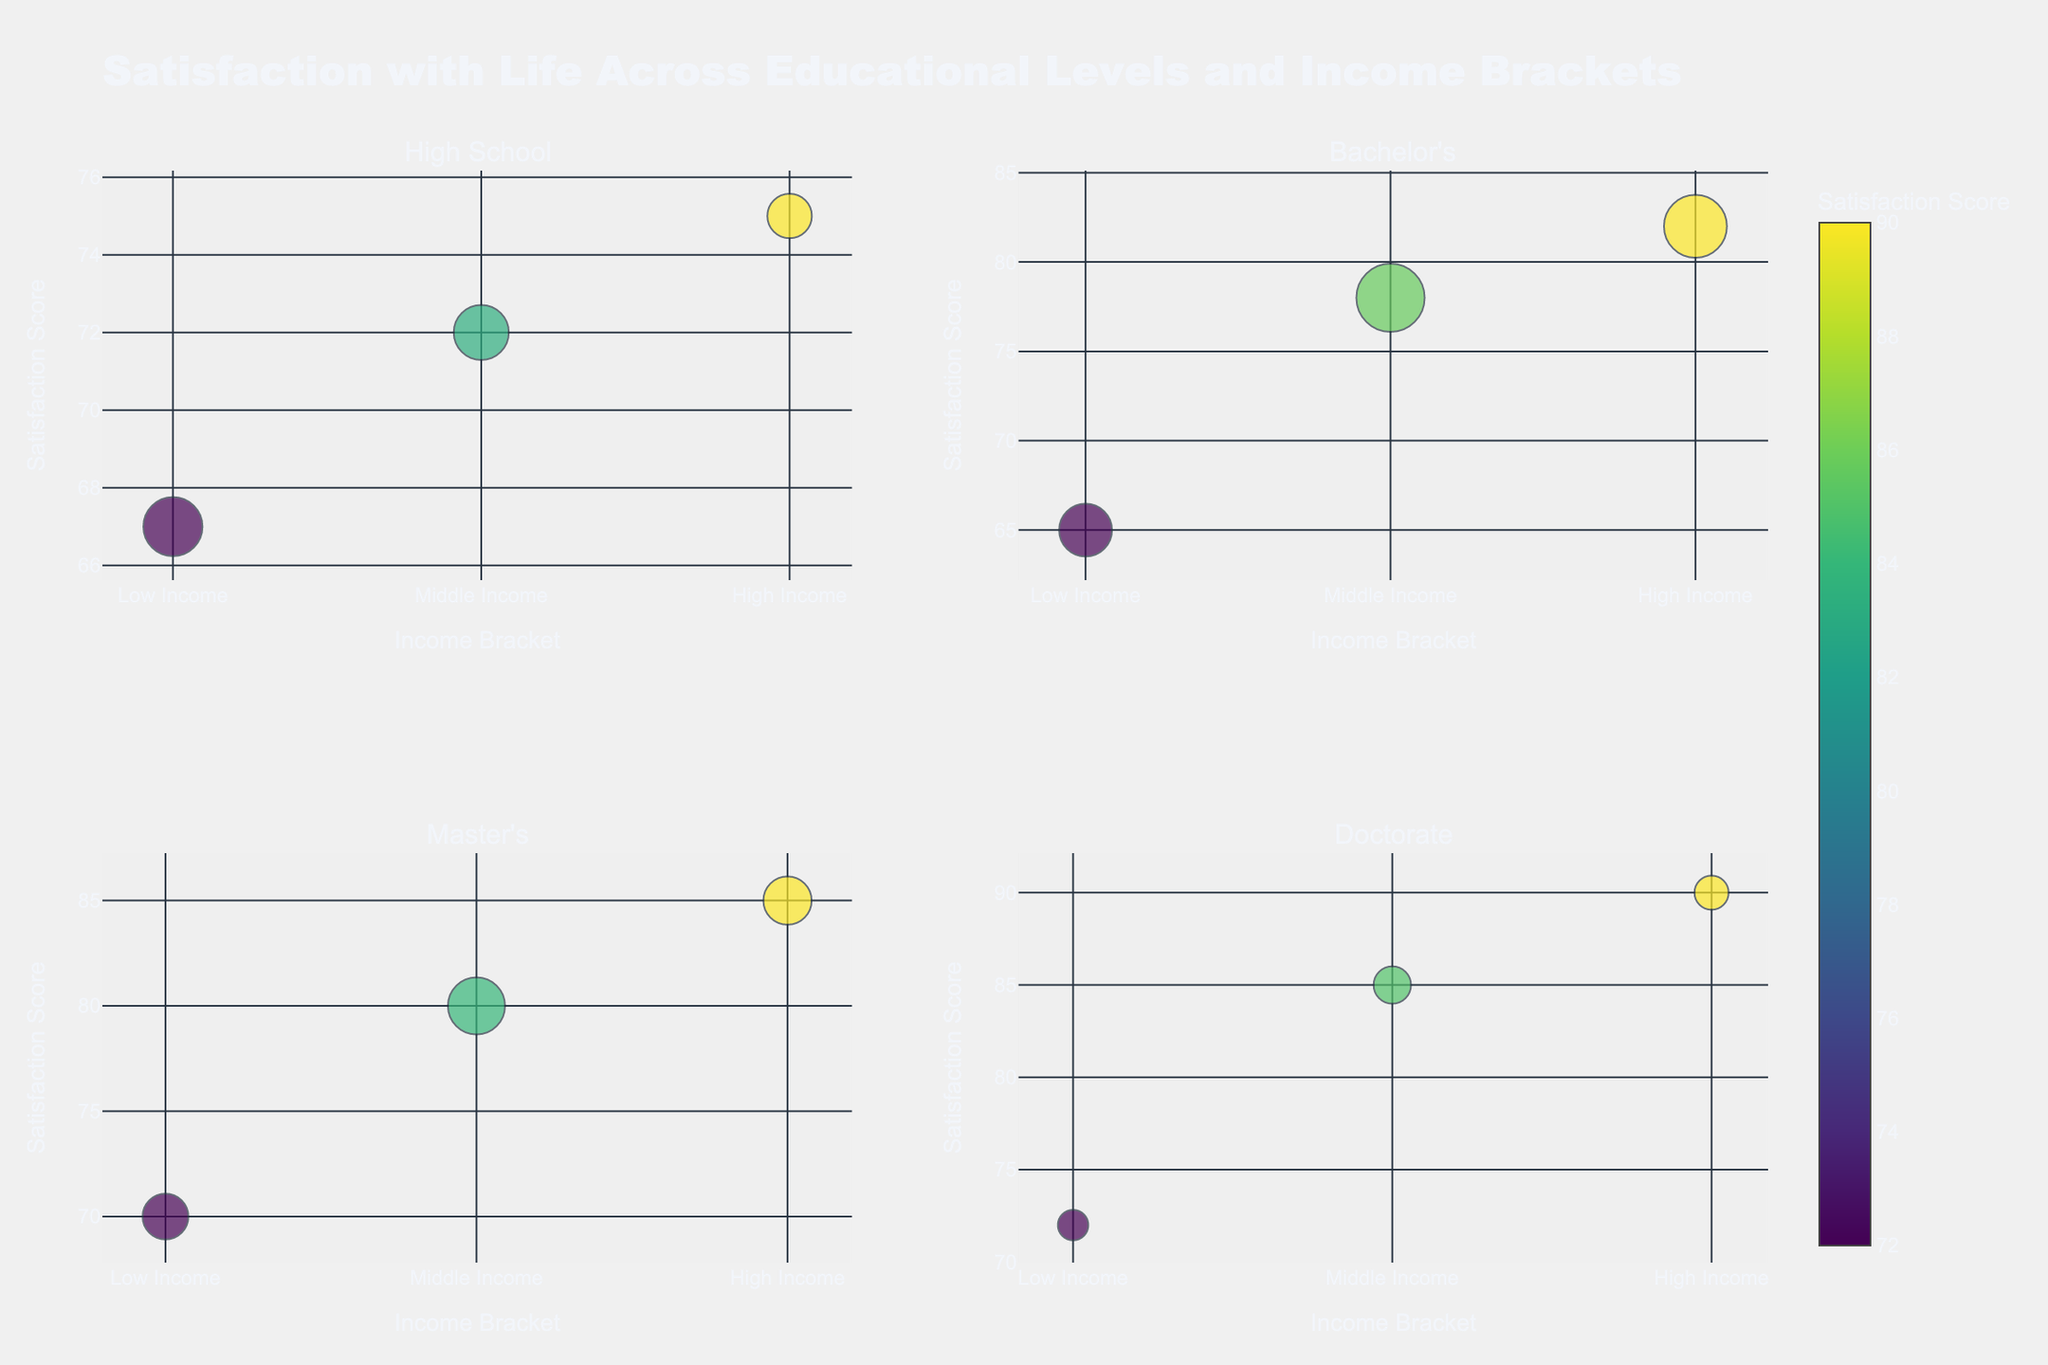What is the title of the plot? The title of the plot is shown at the top-center of the figure.
Answer: Satisfaction with Life Across Educational Levels and Income Brackets Which income bracket in the Bachelor's education level has the highest satisfaction score? To find this, look at the subplot for "Bachelor's" and identify the income bracket with the highest y-axis value for satisfaction score.
Answer: High Income What is the population size for the High School education level in the Low Income bracket? Locate the "High School" subplot, look for the Low Income bracket's bubble, and read the population size in the hover text.
Answer: 150 Compare the satisfaction scores for the highest income bracket across all education levels. Which education level has the highest score? Look at the satisfaction scores for the High Income bracket in each subplot. Compare the y-axis values.
Answer: Doctorate What is the range of satisfaction scores for the Master's education level? Identify the minimum and maximum satisfaction scores in the Master's subplot.
Answer: 70 to 85 Which educational level shows the smallest population size in any income bracket, and what is that population size? Find the smallest bubble across all subplots and refer to its hover text to find the population size.
Answer: Doctorate, Low Income, 40 How does the satisfaction score change from Low Income to High Income for the High School education level? Look at the "High School" subplot and observe the y-axis values for Low Income, Middle Income, and High Income.
Answer: 67 to 75 In the 'Doctorate' education level, what is the difference in satisfaction scores between the Low Income and High Income brackets? Subtract the satisfaction score of Low Income from that of High Income in the 'Doctorate' subplot.
Answer: 18 Which income bracket has the most consistent satisfaction score across all educational levels? Compare the satisfaction scores for Low, Middle, and High Income brackets across all subplots to see which has the least variation.
Answer: High Income For the Bachelor's education level, what is the average satisfaction score across all income brackets? Add the satisfaction scores for Low, Middle, and High Income in the Bachelor's subplot, then divide by 3.
Answer: (65 + 78 + 82) / 3 = 75 